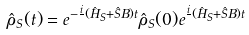Convert formula to latex. <formula><loc_0><loc_0><loc_500><loc_500>\hat { \rho } _ { S } ( t ) = e ^ { - \frac { i } { } ( \hat { H } _ { S } + \hat { S } B ) t } \hat { \rho } _ { S } ( 0 ) e ^ { \frac { i } { } ( \hat { H } _ { S } + \hat { S } B ) t }</formula> 